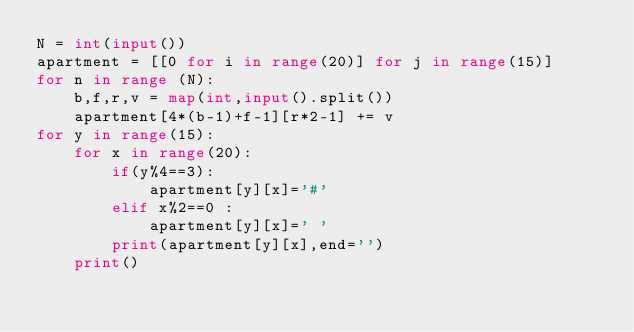<code> <loc_0><loc_0><loc_500><loc_500><_Python_>N = int(input())
apartment = [[0 for i in range(20)] for j in range(15)]
for n in range (N):
    b,f,r,v = map(int,input().split())
    apartment[4*(b-1)+f-1][r*2-1] += v 
for y in range(15):
    for x in range(20):
        if(y%4==3):
            apartment[y][x]='#'
        elif x%2==0 :
            apartment[y][x]=' '
        print(apartment[y][x],end='')
    print()

</code> 